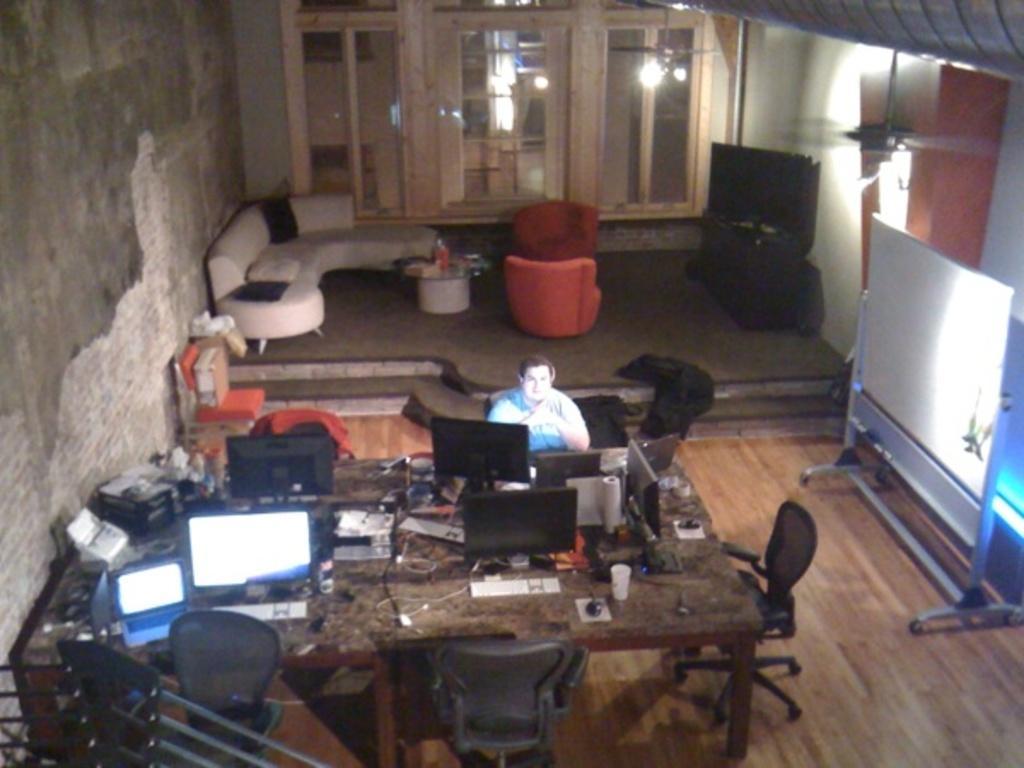In one or two sentences, can you explain what this image depicts? In this image I can see the brown colored floor, the brown colored table and on the table I can see few monitors, few electronic gadgets, few wires and few other objects. I can see chairs around the table, a person sitting on a chair, a white colored board, few couches which are white, black and orange in color, a fan to the ceiling, the wall and few glass doors in which I can see the reflection of few lights. 